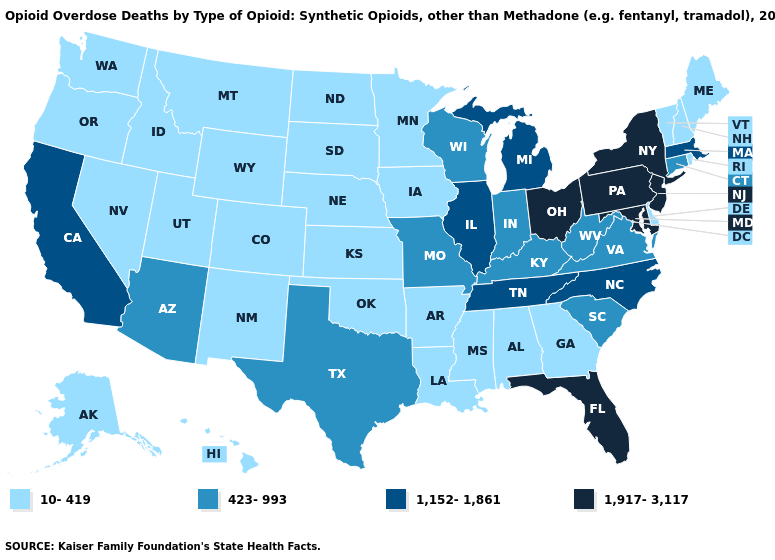Does the first symbol in the legend represent the smallest category?
Keep it brief. Yes. Does Vermont have the highest value in the USA?
Concise answer only. No. Name the states that have a value in the range 10-419?
Write a very short answer. Alabama, Alaska, Arkansas, Colorado, Delaware, Georgia, Hawaii, Idaho, Iowa, Kansas, Louisiana, Maine, Minnesota, Mississippi, Montana, Nebraska, Nevada, New Hampshire, New Mexico, North Dakota, Oklahoma, Oregon, Rhode Island, South Dakota, Utah, Vermont, Washington, Wyoming. What is the highest value in states that border Illinois?
Quick response, please. 423-993. What is the value of Oregon?
Quick response, please. 10-419. Is the legend a continuous bar?
Short answer required. No. What is the value of Delaware?
Be succinct. 10-419. Name the states that have a value in the range 1,152-1,861?
Answer briefly. California, Illinois, Massachusetts, Michigan, North Carolina, Tennessee. Name the states that have a value in the range 1,917-3,117?
Give a very brief answer. Florida, Maryland, New Jersey, New York, Ohio, Pennsylvania. What is the value of Rhode Island?
Be succinct. 10-419. Which states have the lowest value in the USA?
Quick response, please. Alabama, Alaska, Arkansas, Colorado, Delaware, Georgia, Hawaii, Idaho, Iowa, Kansas, Louisiana, Maine, Minnesota, Mississippi, Montana, Nebraska, Nevada, New Hampshire, New Mexico, North Dakota, Oklahoma, Oregon, Rhode Island, South Dakota, Utah, Vermont, Washington, Wyoming. What is the value of Colorado?
Short answer required. 10-419. What is the highest value in the West ?
Be succinct. 1,152-1,861. Does Montana have the lowest value in the West?
Concise answer only. Yes. 